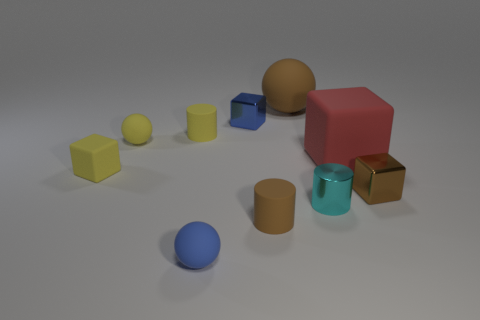There is a cyan shiny object; is it the same size as the yellow thing that is in front of the big red object?
Provide a succinct answer. Yes. Are there any other things that have the same shape as the large red matte object?
Your answer should be compact. Yes. The other small rubber object that is the same shape as the blue rubber thing is what color?
Provide a succinct answer. Yellow. Do the brown ball and the blue cube have the same size?
Keep it short and to the point. No. How many other objects are there of the same size as the brown metallic block?
Give a very brief answer. 7. How many things are big objects left of the tiny cyan cylinder or small matte cylinders to the right of the tiny yellow matte cylinder?
Your answer should be compact. 2. What shape is the cyan shiny thing that is the same size as the blue metallic cube?
Offer a terse response. Cylinder. There is a blue thing that is the same material as the large cube; what is its size?
Your answer should be very brief. Small. Do the blue metallic object and the brown shiny object have the same shape?
Offer a terse response. Yes. The rubber block that is the same size as the cyan cylinder is what color?
Your answer should be compact. Yellow. 